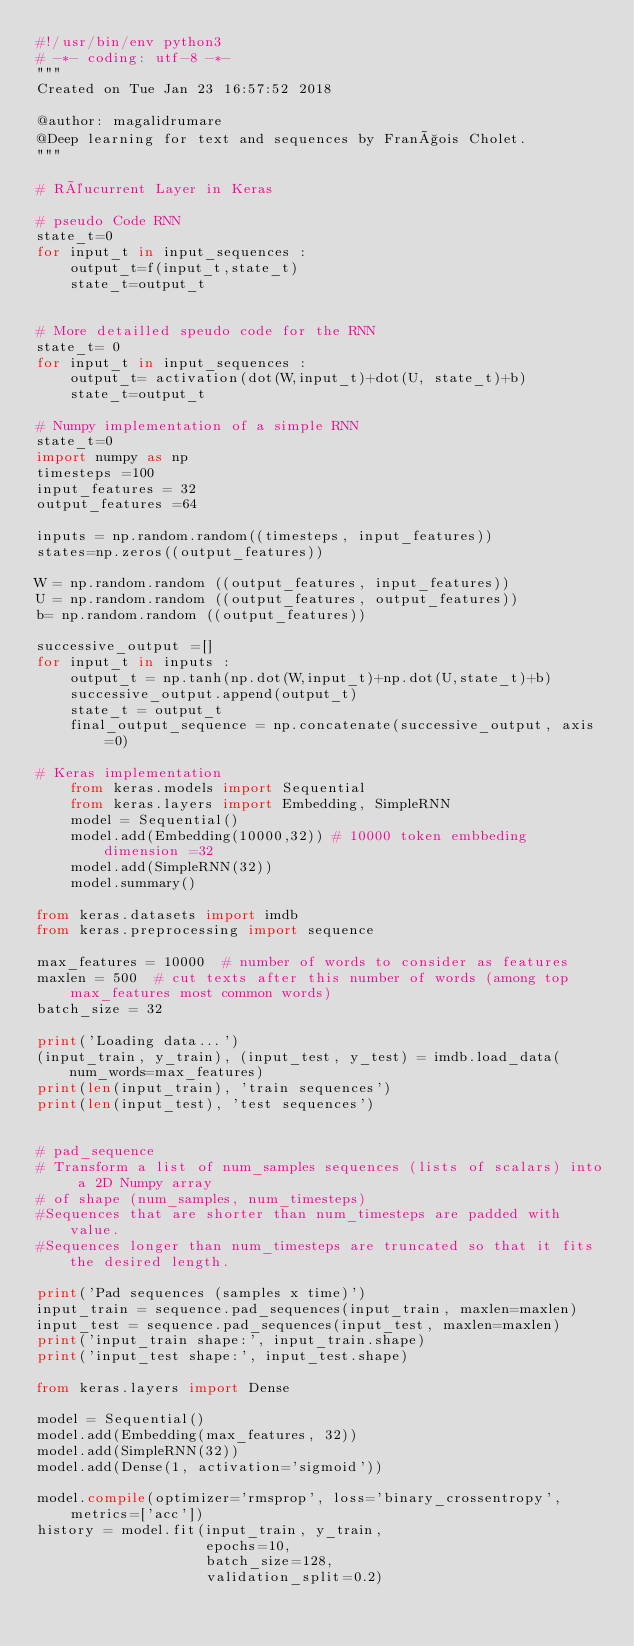Convert code to text. <code><loc_0><loc_0><loc_500><loc_500><_Python_>#!/usr/bin/env python3
# -*- coding: utf-8 -*-
"""
Created on Tue Jan 23 16:57:52 2018

@author: magalidrumare
@Deep learning for text and sequences by François Cholet.  
"""

# Réucurrent Layer in Keras 

# pseudo Code RNN 
state_t=0
for input_t in input_sequences : 
    output_t=f(input_t,state_t)
    state_t=output_t
    
    
# More detailled speudo code for the RNN 
state_t= 0 
for input_t in input_sequences : 
    output_t= activation(dot(W,input_t)+dot(U, state_t)+b)
    state_t=output_t

# Numpy implementation of a simple RNN 
state_t=0
import numpy as np 
timesteps =100 
input_features = 32 
output_features =64

inputs = np.random.random((timesteps, input_features))
states=np.zeros((output_features))

W = np.random.random ((output_features, input_features))
U = np.random.random ((output_features, output_features))
b= np.random.random ((output_features))

successive_output =[]
for input_t in inputs : 
    output_t = np.tanh(np.dot(W,input_t)+np.dot(U,state_t)+b)
    successive_output.append(output_t)
    state_t = output_t
    final_output_sequence = np.concatenate(successive_output, axis=0)
    
# Keras implementation 
    from keras.models import Sequential 
    from keras.layers import Embedding, SimpleRNN
    model = Sequential()
    model.add(Embedding(10000,32)) # 10000 token embbeding dimension =32
    model.add(SimpleRNN(32))
    model.summary()
    
from keras.datasets import imdb
from keras.preprocessing import sequence

max_features = 10000  # number of words to consider as features
maxlen = 500  # cut texts after this number of words (among top max_features most common words)
batch_size = 32

print('Loading data...')
(input_train, y_train), (input_test, y_test) = imdb.load_data(num_words=max_features)
print(len(input_train), 'train sequences')
print(len(input_test), 'test sequences')


# pad_sequence 
# Transform a list of num_samples sequences (lists of scalars) into a 2D Numpy array
# of shape (num_samples, num_timesteps)
#Sequences that are shorter than num_timesteps are padded with value. 
#Sequences longer than num_timesteps are truncated so that it fits the desired length. 

print('Pad sequences (samples x time)')
input_train = sequence.pad_sequences(input_train, maxlen=maxlen)
input_test = sequence.pad_sequences(input_test, maxlen=maxlen)
print('input_train shape:', input_train.shape)
print('input_test shape:', input_test.shape)

from keras.layers import Dense

model = Sequential()
model.add(Embedding(max_features, 32))
model.add(SimpleRNN(32))
model.add(Dense(1, activation='sigmoid'))

model.compile(optimizer='rmsprop', loss='binary_crossentropy', metrics=['acc'])
history = model.fit(input_train, y_train,
                    epochs=10,
                    batch_size=128,
                    validation_split=0.2)


</code> 